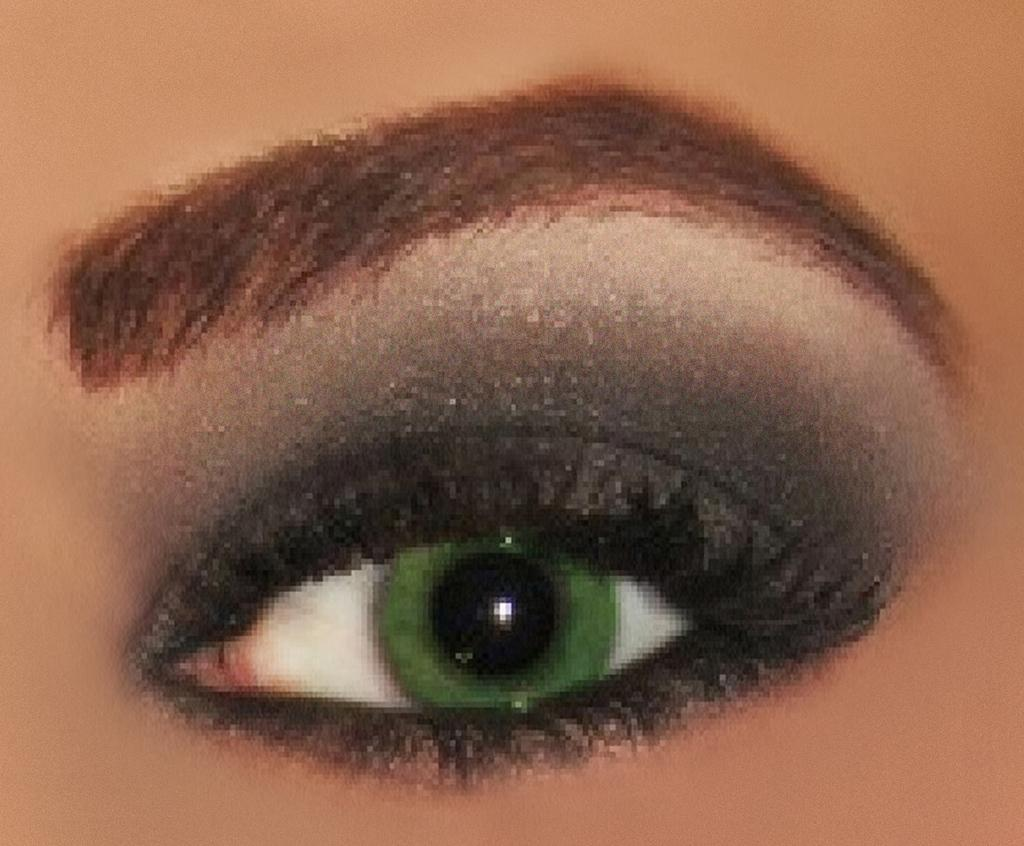What is the main subject of the image? The main subject of the image is a person's eye. What color is the lens in the eye? The eye has a green lens. What can be seen on the eyelid? There is eye makeup on the eyelid. What other facial feature is visible in the image? There is an eyebrow visible in the image. How many eggs are visible in the image? There are no eggs present in the image; it features a person's eye with a green lens and eye makeup. What type of wine is being poured in the image? There is no wine present in the image; it features a person's eye with a green lens and eye makeup. 